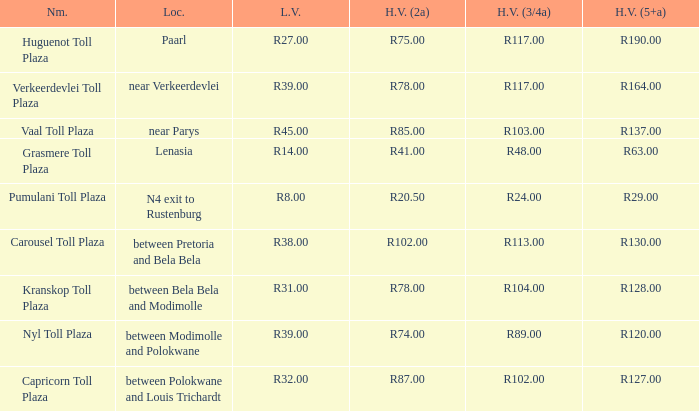What is the name of the plaza where the toll for heavy vehicles with 2 axles is r87.00? Capricorn Toll Plaza. 